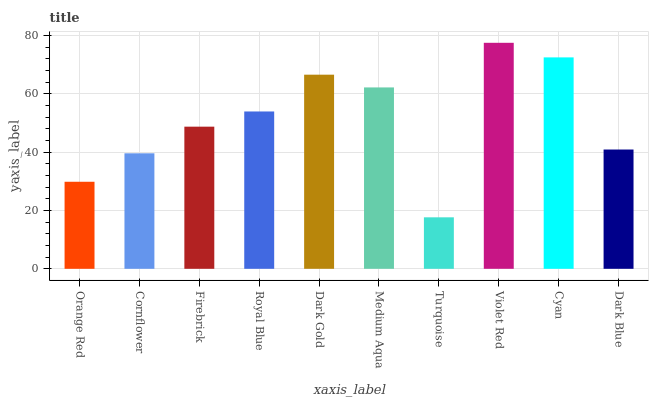Is Turquoise the minimum?
Answer yes or no. Yes. Is Violet Red the maximum?
Answer yes or no. Yes. Is Cornflower the minimum?
Answer yes or no. No. Is Cornflower the maximum?
Answer yes or no. No. Is Cornflower greater than Orange Red?
Answer yes or no. Yes. Is Orange Red less than Cornflower?
Answer yes or no. Yes. Is Orange Red greater than Cornflower?
Answer yes or no. No. Is Cornflower less than Orange Red?
Answer yes or no. No. Is Royal Blue the high median?
Answer yes or no. Yes. Is Firebrick the low median?
Answer yes or no. Yes. Is Dark Gold the high median?
Answer yes or no. No. Is Dark Blue the low median?
Answer yes or no. No. 